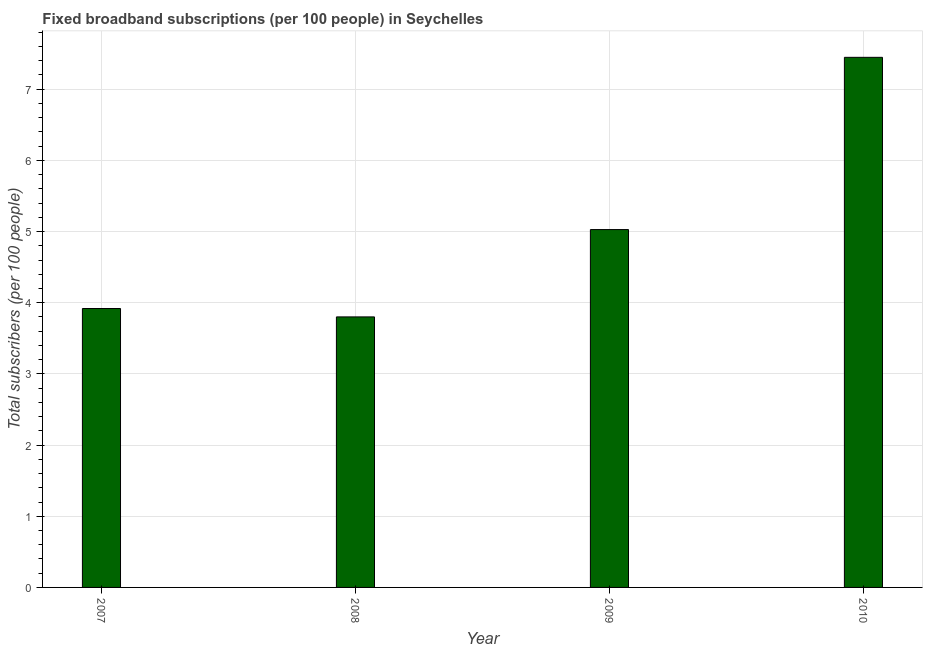Does the graph contain grids?
Your response must be concise. Yes. What is the title of the graph?
Make the answer very short. Fixed broadband subscriptions (per 100 people) in Seychelles. What is the label or title of the X-axis?
Your response must be concise. Year. What is the label or title of the Y-axis?
Your answer should be very brief. Total subscribers (per 100 people). What is the total number of fixed broadband subscriptions in 2008?
Provide a short and direct response. 3.8. Across all years, what is the maximum total number of fixed broadband subscriptions?
Provide a short and direct response. 7.45. Across all years, what is the minimum total number of fixed broadband subscriptions?
Give a very brief answer. 3.8. In which year was the total number of fixed broadband subscriptions maximum?
Make the answer very short. 2010. In which year was the total number of fixed broadband subscriptions minimum?
Offer a terse response. 2008. What is the sum of the total number of fixed broadband subscriptions?
Provide a short and direct response. 20.2. What is the difference between the total number of fixed broadband subscriptions in 2007 and 2010?
Give a very brief answer. -3.53. What is the average total number of fixed broadband subscriptions per year?
Give a very brief answer. 5.05. What is the median total number of fixed broadband subscriptions?
Provide a succinct answer. 4.47. In how many years, is the total number of fixed broadband subscriptions greater than 0.8 ?
Provide a succinct answer. 4. What is the ratio of the total number of fixed broadband subscriptions in 2009 to that in 2010?
Offer a very short reply. 0.68. What is the difference between the highest and the second highest total number of fixed broadband subscriptions?
Provide a short and direct response. 2.42. Is the sum of the total number of fixed broadband subscriptions in 2008 and 2010 greater than the maximum total number of fixed broadband subscriptions across all years?
Provide a succinct answer. Yes. What is the difference between the highest and the lowest total number of fixed broadband subscriptions?
Your response must be concise. 3.65. How many bars are there?
Your response must be concise. 4. How many years are there in the graph?
Keep it short and to the point. 4. Are the values on the major ticks of Y-axis written in scientific E-notation?
Make the answer very short. No. What is the Total subscribers (per 100 people) of 2007?
Keep it short and to the point. 3.92. What is the Total subscribers (per 100 people) of 2008?
Ensure brevity in your answer.  3.8. What is the Total subscribers (per 100 people) of 2009?
Offer a terse response. 5.03. What is the Total subscribers (per 100 people) in 2010?
Offer a very short reply. 7.45. What is the difference between the Total subscribers (per 100 people) in 2007 and 2008?
Give a very brief answer. 0.12. What is the difference between the Total subscribers (per 100 people) in 2007 and 2009?
Offer a terse response. -1.11. What is the difference between the Total subscribers (per 100 people) in 2007 and 2010?
Your response must be concise. -3.53. What is the difference between the Total subscribers (per 100 people) in 2008 and 2009?
Your response must be concise. -1.23. What is the difference between the Total subscribers (per 100 people) in 2008 and 2010?
Provide a short and direct response. -3.65. What is the difference between the Total subscribers (per 100 people) in 2009 and 2010?
Ensure brevity in your answer.  -2.42. What is the ratio of the Total subscribers (per 100 people) in 2007 to that in 2008?
Your response must be concise. 1.03. What is the ratio of the Total subscribers (per 100 people) in 2007 to that in 2009?
Give a very brief answer. 0.78. What is the ratio of the Total subscribers (per 100 people) in 2007 to that in 2010?
Provide a short and direct response. 0.53. What is the ratio of the Total subscribers (per 100 people) in 2008 to that in 2009?
Provide a succinct answer. 0.76. What is the ratio of the Total subscribers (per 100 people) in 2008 to that in 2010?
Offer a terse response. 0.51. What is the ratio of the Total subscribers (per 100 people) in 2009 to that in 2010?
Your answer should be compact. 0.68. 